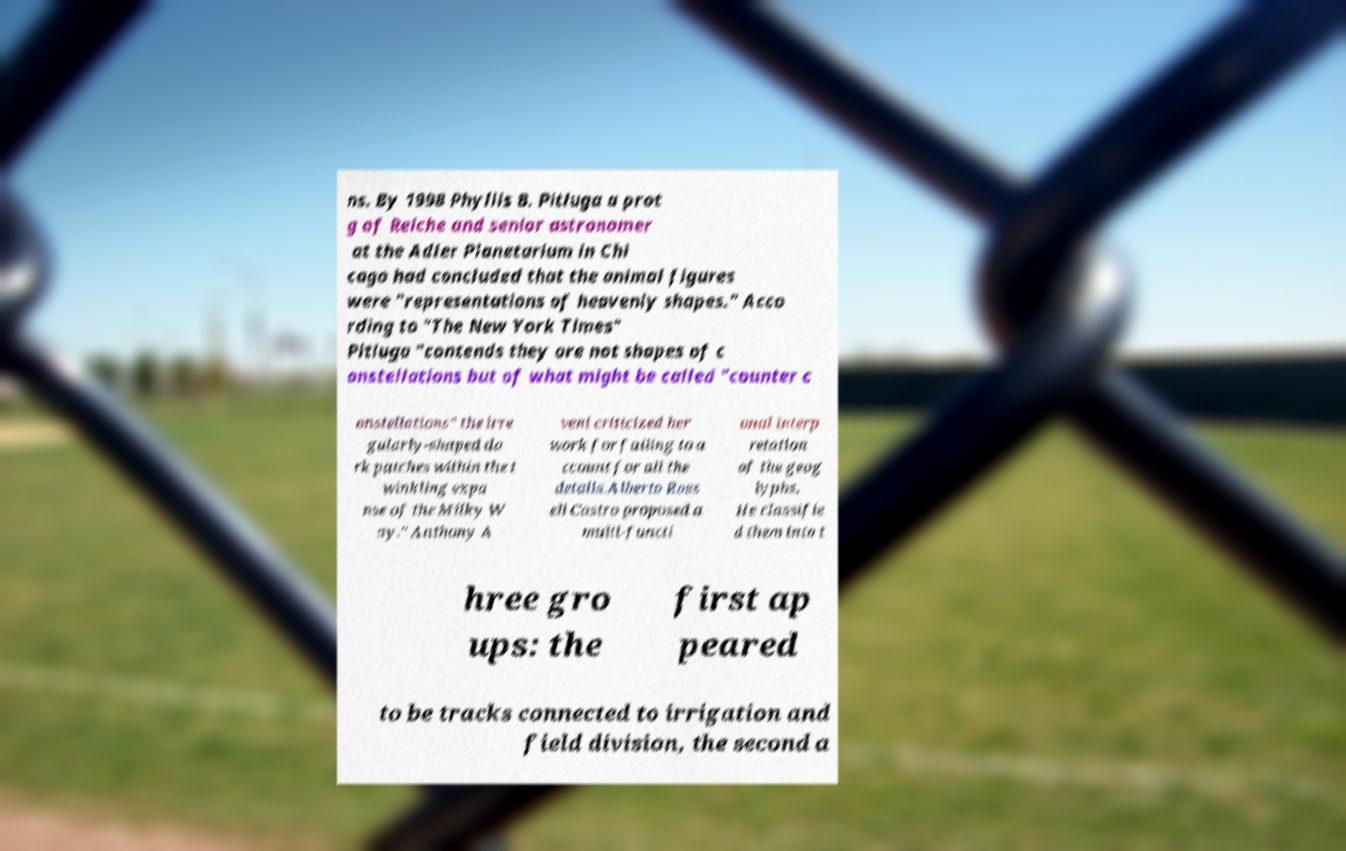Could you assist in decoding the text presented in this image and type it out clearly? ns. By 1998 Phyllis B. Pitluga a prot g of Reiche and senior astronomer at the Adler Planetarium in Chi cago had concluded that the animal figures were "representations of heavenly shapes." Acco rding to "The New York Times" Pitluga "contends they are not shapes of c onstellations but of what might be called "counter c onstellations" the irre gularly-shaped da rk patches within the t winkling expa nse of the Milky W ay." Anthony A veni criticized her work for failing to a ccount for all the details.Alberto Ross ell Castro proposed a multi-functi onal interp retation of the geog lyphs. He classifie d them into t hree gro ups: the first ap peared to be tracks connected to irrigation and field division, the second a 